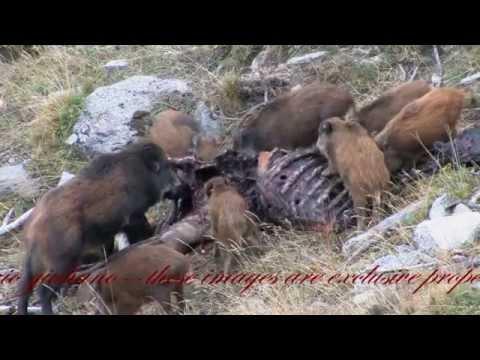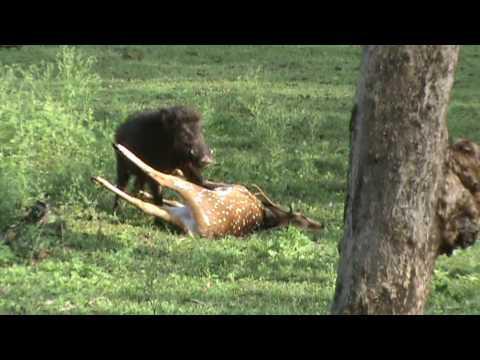The first image is the image on the left, the second image is the image on the right. Evaluate the accuracy of this statement regarding the images: "Some of the pigs are standing in snow.". Is it true? Answer yes or no. No. 